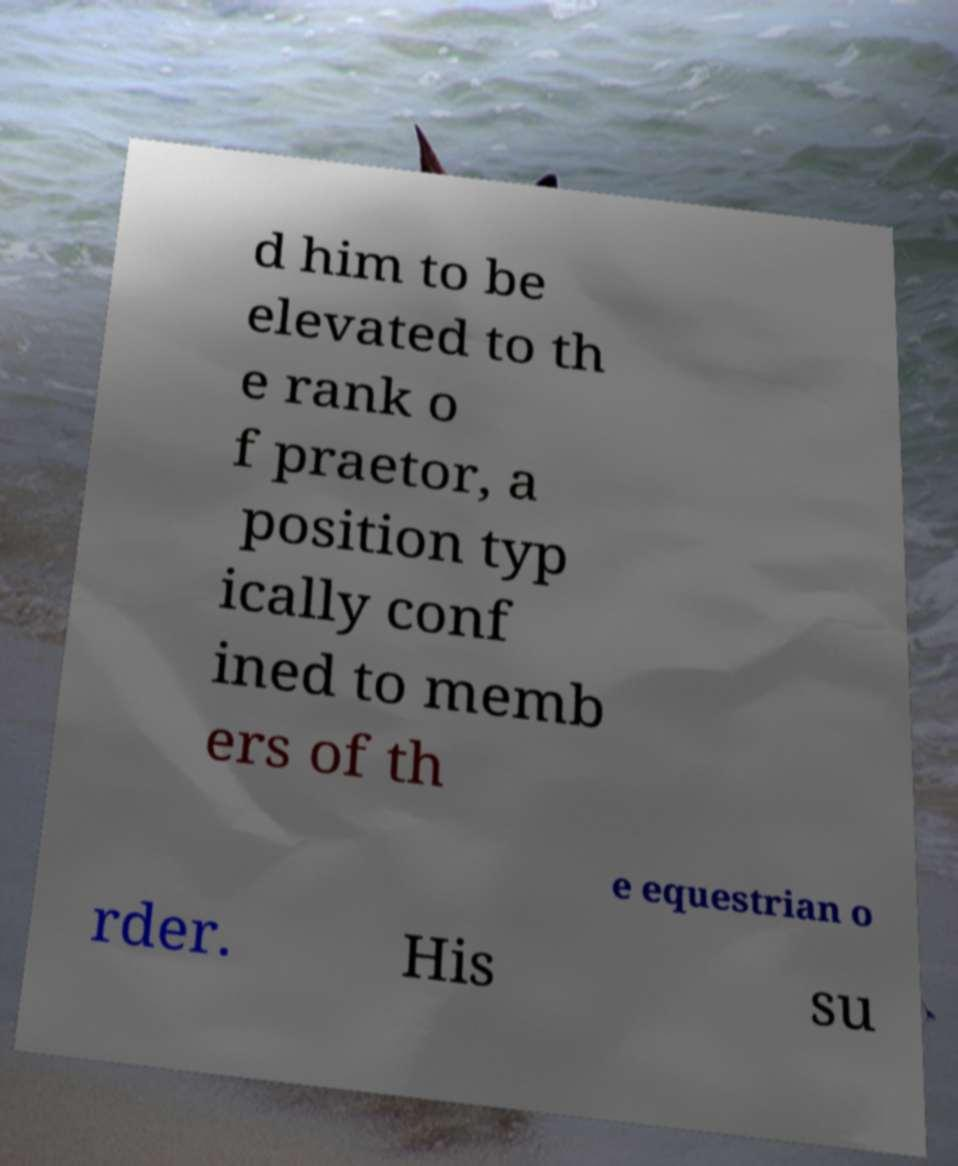Can you read and provide the text displayed in the image?This photo seems to have some interesting text. Can you extract and type it out for me? d him to be elevated to th e rank o f praetor, a position typ ically conf ined to memb ers of th e equestrian o rder. His su 